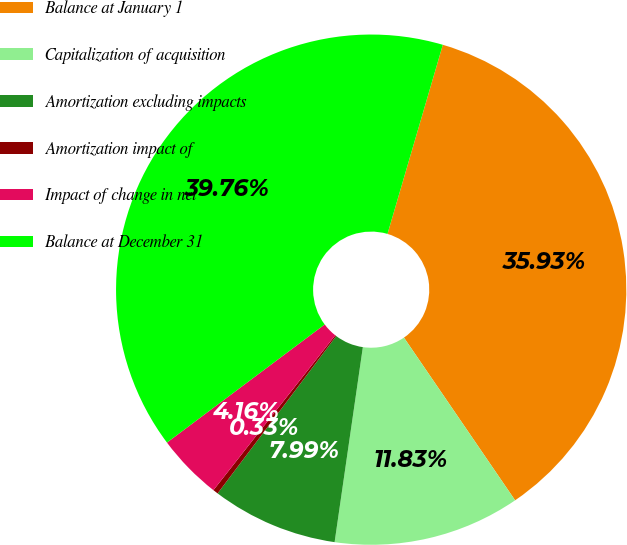<chart> <loc_0><loc_0><loc_500><loc_500><pie_chart><fcel>Balance at January 1<fcel>Capitalization of acquisition<fcel>Amortization excluding impacts<fcel>Amortization impact of<fcel>Impact of change in net<fcel>Balance at December 31<nl><fcel>35.93%<fcel>11.83%<fcel>7.99%<fcel>0.33%<fcel>4.16%<fcel>39.76%<nl></chart> 